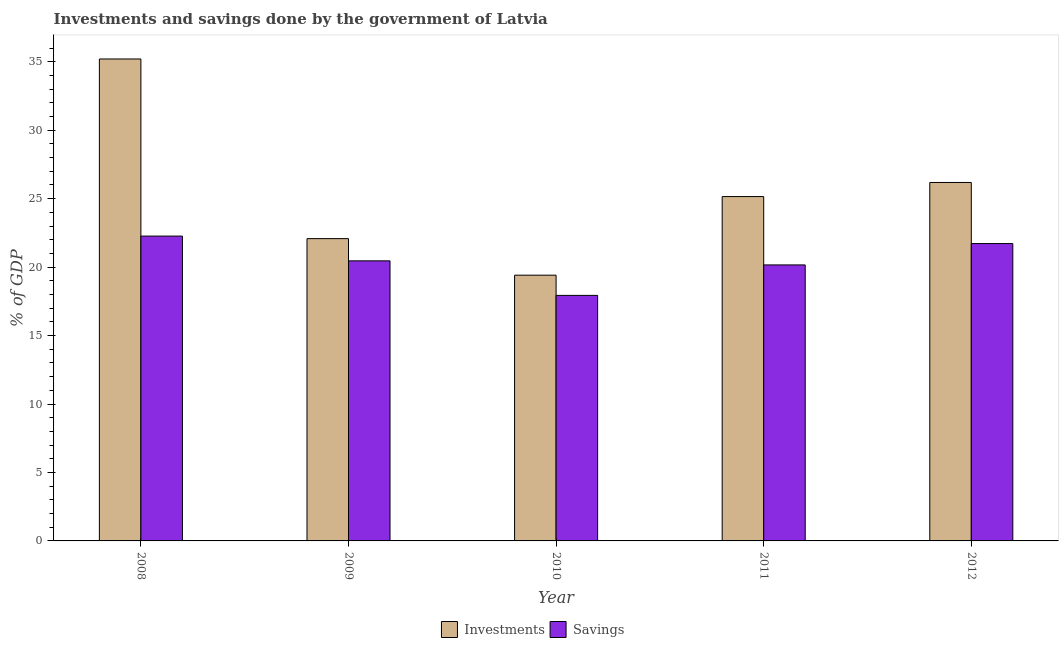How many different coloured bars are there?
Offer a terse response. 2. How many groups of bars are there?
Make the answer very short. 5. Are the number of bars per tick equal to the number of legend labels?
Provide a short and direct response. Yes. What is the label of the 4th group of bars from the left?
Offer a terse response. 2011. What is the savings of government in 2010?
Give a very brief answer. 17.93. Across all years, what is the maximum investments of government?
Give a very brief answer. 35.2. Across all years, what is the minimum savings of government?
Make the answer very short. 17.93. In which year was the investments of government maximum?
Your answer should be very brief. 2008. In which year was the savings of government minimum?
Your response must be concise. 2010. What is the total investments of government in the graph?
Give a very brief answer. 128.02. What is the difference between the investments of government in 2008 and that in 2012?
Your answer should be very brief. 9.02. What is the difference between the investments of government in 2009 and the savings of government in 2008?
Your answer should be compact. -13.12. What is the average savings of government per year?
Ensure brevity in your answer.  20.51. In how many years, is the savings of government greater than 30 %?
Your response must be concise. 0. What is the ratio of the investments of government in 2011 to that in 2012?
Ensure brevity in your answer.  0.96. Is the savings of government in 2008 less than that in 2011?
Offer a terse response. No. What is the difference between the highest and the second highest savings of government?
Offer a terse response. 0.55. What is the difference between the highest and the lowest investments of government?
Your answer should be compact. 15.79. What does the 1st bar from the left in 2008 represents?
Offer a terse response. Investments. What does the 2nd bar from the right in 2011 represents?
Ensure brevity in your answer.  Investments. How many bars are there?
Provide a succinct answer. 10. Are all the bars in the graph horizontal?
Your response must be concise. No. Are the values on the major ticks of Y-axis written in scientific E-notation?
Ensure brevity in your answer.  No. Where does the legend appear in the graph?
Provide a short and direct response. Bottom center. How are the legend labels stacked?
Ensure brevity in your answer.  Horizontal. What is the title of the graph?
Your answer should be compact. Investments and savings done by the government of Latvia. Does "Highest 10% of population" appear as one of the legend labels in the graph?
Keep it short and to the point. No. What is the label or title of the Y-axis?
Make the answer very short. % of GDP. What is the % of GDP of Investments in 2008?
Give a very brief answer. 35.2. What is the % of GDP of Savings in 2008?
Provide a short and direct response. 22.27. What is the % of GDP of Investments in 2009?
Your answer should be very brief. 22.08. What is the % of GDP of Savings in 2009?
Keep it short and to the point. 20.46. What is the % of GDP in Investments in 2010?
Ensure brevity in your answer.  19.41. What is the % of GDP in Savings in 2010?
Keep it short and to the point. 17.93. What is the % of GDP in Investments in 2011?
Keep it short and to the point. 25.15. What is the % of GDP of Savings in 2011?
Offer a very short reply. 20.16. What is the % of GDP of Investments in 2012?
Offer a terse response. 26.18. What is the % of GDP in Savings in 2012?
Provide a short and direct response. 21.72. Across all years, what is the maximum % of GDP in Investments?
Give a very brief answer. 35.2. Across all years, what is the maximum % of GDP in Savings?
Your answer should be very brief. 22.27. Across all years, what is the minimum % of GDP of Investments?
Provide a succinct answer. 19.41. Across all years, what is the minimum % of GDP in Savings?
Give a very brief answer. 17.93. What is the total % of GDP in Investments in the graph?
Make the answer very short. 128.02. What is the total % of GDP of Savings in the graph?
Make the answer very short. 102.53. What is the difference between the % of GDP in Investments in 2008 and that in 2009?
Keep it short and to the point. 13.12. What is the difference between the % of GDP in Savings in 2008 and that in 2009?
Offer a terse response. 1.81. What is the difference between the % of GDP of Investments in 2008 and that in 2010?
Provide a short and direct response. 15.79. What is the difference between the % of GDP in Savings in 2008 and that in 2010?
Provide a succinct answer. 4.33. What is the difference between the % of GDP of Investments in 2008 and that in 2011?
Your answer should be compact. 10.05. What is the difference between the % of GDP in Savings in 2008 and that in 2011?
Keep it short and to the point. 2.11. What is the difference between the % of GDP of Investments in 2008 and that in 2012?
Provide a short and direct response. 9.02. What is the difference between the % of GDP of Savings in 2008 and that in 2012?
Your answer should be compact. 0.55. What is the difference between the % of GDP in Investments in 2009 and that in 2010?
Make the answer very short. 2.67. What is the difference between the % of GDP of Savings in 2009 and that in 2010?
Your response must be concise. 2.52. What is the difference between the % of GDP in Investments in 2009 and that in 2011?
Your answer should be very brief. -3.07. What is the difference between the % of GDP of Savings in 2009 and that in 2011?
Provide a short and direct response. 0.3. What is the difference between the % of GDP of Investments in 2009 and that in 2012?
Your answer should be very brief. -4.1. What is the difference between the % of GDP in Savings in 2009 and that in 2012?
Give a very brief answer. -1.26. What is the difference between the % of GDP in Investments in 2010 and that in 2011?
Ensure brevity in your answer.  -5.74. What is the difference between the % of GDP in Savings in 2010 and that in 2011?
Make the answer very short. -2.22. What is the difference between the % of GDP in Investments in 2010 and that in 2012?
Keep it short and to the point. -6.77. What is the difference between the % of GDP of Savings in 2010 and that in 2012?
Offer a terse response. -3.78. What is the difference between the % of GDP in Investments in 2011 and that in 2012?
Offer a very short reply. -1.03. What is the difference between the % of GDP of Savings in 2011 and that in 2012?
Your response must be concise. -1.56. What is the difference between the % of GDP in Investments in 2008 and the % of GDP in Savings in 2009?
Provide a succinct answer. 14.74. What is the difference between the % of GDP of Investments in 2008 and the % of GDP of Savings in 2010?
Provide a succinct answer. 17.27. What is the difference between the % of GDP in Investments in 2008 and the % of GDP in Savings in 2011?
Give a very brief answer. 15.04. What is the difference between the % of GDP in Investments in 2008 and the % of GDP in Savings in 2012?
Provide a short and direct response. 13.48. What is the difference between the % of GDP in Investments in 2009 and the % of GDP in Savings in 2010?
Your answer should be compact. 4.14. What is the difference between the % of GDP of Investments in 2009 and the % of GDP of Savings in 2011?
Your response must be concise. 1.92. What is the difference between the % of GDP of Investments in 2009 and the % of GDP of Savings in 2012?
Your answer should be compact. 0.36. What is the difference between the % of GDP in Investments in 2010 and the % of GDP in Savings in 2011?
Offer a terse response. -0.75. What is the difference between the % of GDP of Investments in 2010 and the % of GDP of Savings in 2012?
Your answer should be very brief. -2.31. What is the difference between the % of GDP of Investments in 2011 and the % of GDP of Savings in 2012?
Offer a very short reply. 3.43. What is the average % of GDP in Investments per year?
Provide a short and direct response. 25.6. What is the average % of GDP in Savings per year?
Ensure brevity in your answer.  20.51. In the year 2008, what is the difference between the % of GDP of Investments and % of GDP of Savings?
Your answer should be very brief. 12.94. In the year 2009, what is the difference between the % of GDP of Investments and % of GDP of Savings?
Your answer should be very brief. 1.62. In the year 2010, what is the difference between the % of GDP of Investments and % of GDP of Savings?
Make the answer very short. 1.48. In the year 2011, what is the difference between the % of GDP of Investments and % of GDP of Savings?
Your answer should be very brief. 4.99. In the year 2012, what is the difference between the % of GDP in Investments and % of GDP in Savings?
Your answer should be compact. 4.46. What is the ratio of the % of GDP of Investments in 2008 to that in 2009?
Provide a short and direct response. 1.59. What is the ratio of the % of GDP of Savings in 2008 to that in 2009?
Make the answer very short. 1.09. What is the ratio of the % of GDP in Investments in 2008 to that in 2010?
Your answer should be very brief. 1.81. What is the ratio of the % of GDP in Savings in 2008 to that in 2010?
Keep it short and to the point. 1.24. What is the ratio of the % of GDP of Investments in 2008 to that in 2011?
Your response must be concise. 1.4. What is the ratio of the % of GDP of Savings in 2008 to that in 2011?
Provide a succinct answer. 1.1. What is the ratio of the % of GDP of Investments in 2008 to that in 2012?
Give a very brief answer. 1.34. What is the ratio of the % of GDP in Savings in 2008 to that in 2012?
Your response must be concise. 1.03. What is the ratio of the % of GDP in Investments in 2009 to that in 2010?
Provide a short and direct response. 1.14. What is the ratio of the % of GDP of Savings in 2009 to that in 2010?
Your answer should be compact. 1.14. What is the ratio of the % of GDP of Investments in 2009 to that in 2011?
Your answer should be very brief. 0.88. What is the ratio of the % of GDP in Savings in 2009 to that in 2011?
Ensure brevity in your answer.  1.01. What is the ratio of the % of GDP in Investments in 2009 to that in 2012?
Keep it short and to the point. 0.84. What is the ratio of the % of GDP of Savings in 2009 to that in 2012?
Your response must be concise. 0.94. What is the ratio of the % of GDP of Investments in 2010 to that in 2011?
Your response must be concise. 0.77. What is the ratio of the % of GDP in Savings in 2010 to that in 2011?
Give a very brief answer. 0.89. What is the ratio of the % of GDP in Investments in 2010 to that in 2012?
Provide a short and direct response. 0.74. What is the ratio of the % of GDP in Savings in 2010 to that in 2012?
Your answer should be very brief. 0.83. What is the ratio of the % of GDP of Investments in 2011 to that in 2012?
Offer a very short reply. 0.96. What is the ratio of the % of GDP of Savings in 2011 to that in 2012?
Your response must be concise. 0.93. What is the difference between the highest and the second highest % of GDP in Investments?
Offer a very short reply. 9.02. What is the difference between the highest and the second highest % of GDP of Savings?
Offer a terse response. 0.55. What is the difference between the highest and the lowest % of GDP of Investments?
Your answer should be very brief. 15.79. What is the difference between the highest and the lowest % of GDP of Savings?
Your answer should be very brief. 4.33. 